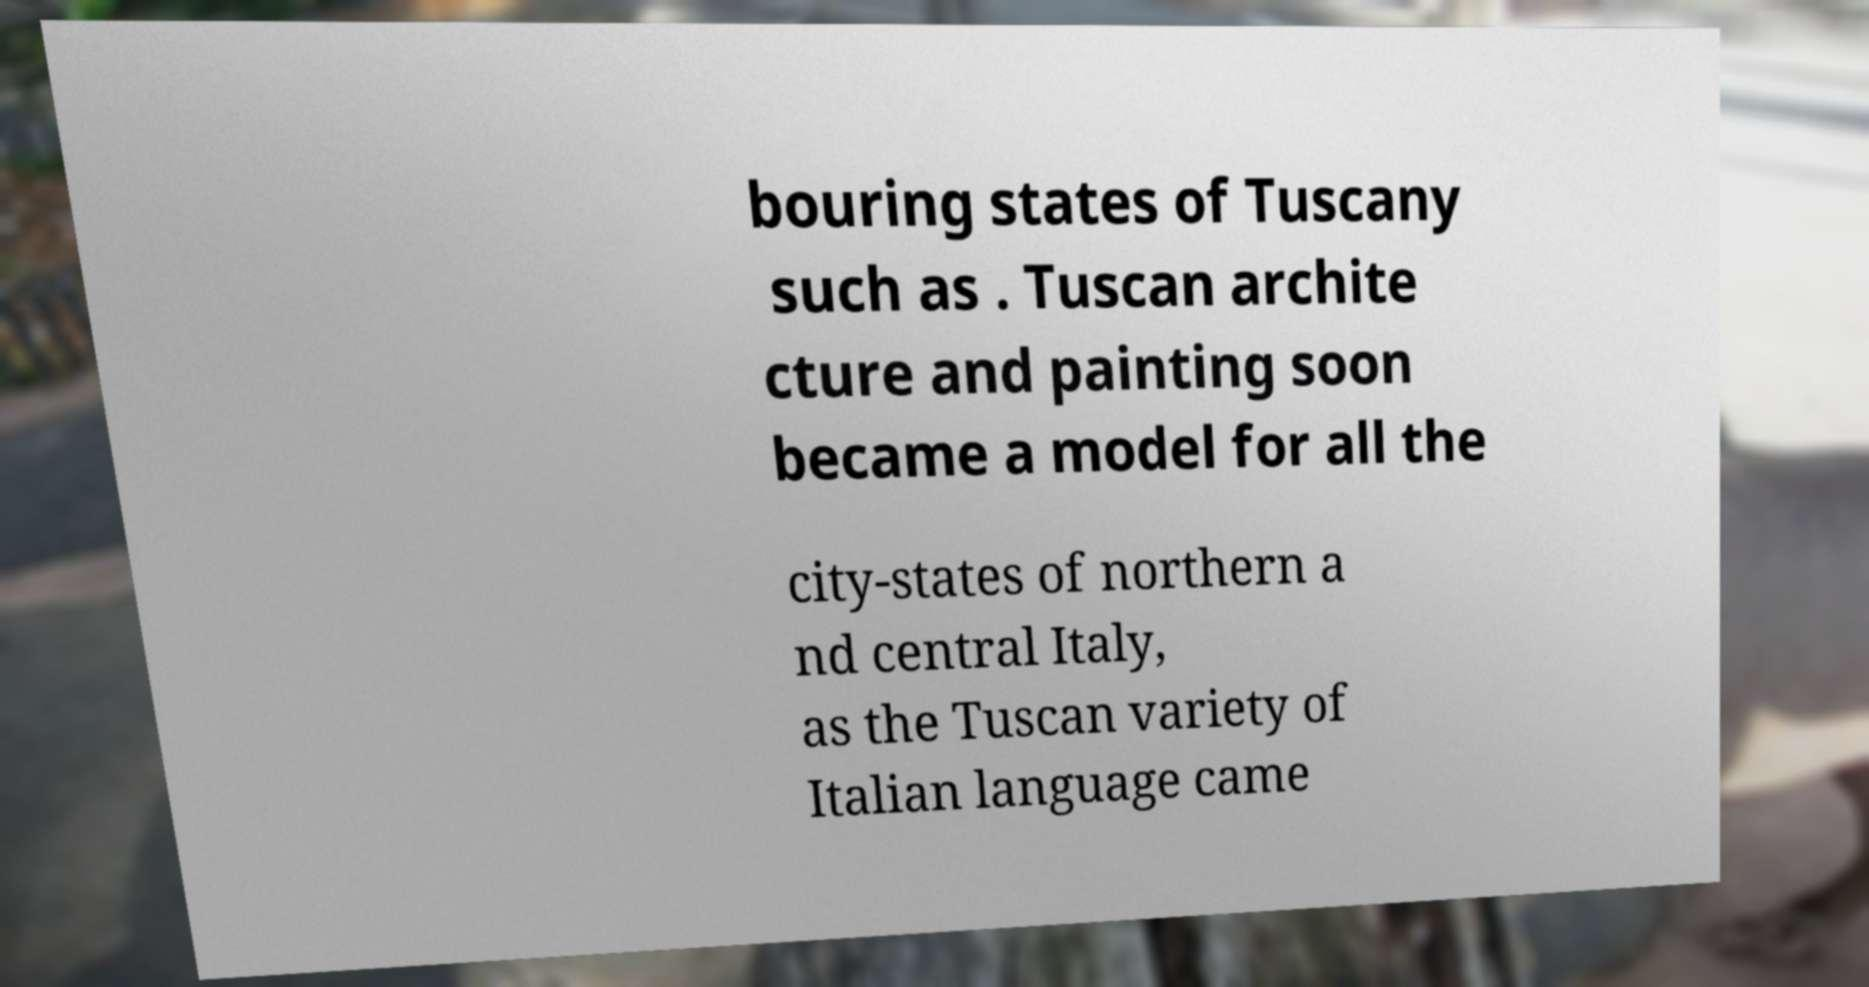Can you read and provide the text displayed in the image?This photo seems to have some interesting text. Can you extract and type it out for me? bouring states of Tuscany such as . Tuscan archite cture and painting soon became a model for all the city-states of northern a nd central Italy, as the Tuscan variety of Italian language came 